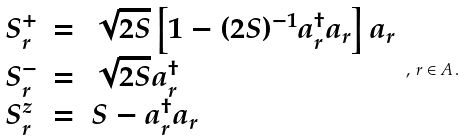<formula> <loc_0><loc_0><loc_500><loc_500>\begin{array} { l c l } S ^ { + } _ { r } & = & \sqrt { 2 S } \left [ 1 - ( 2 S ) ^ { - 1 } a _ { r } ^ { \dagger } a _ { r } \right ] a _ { r } \\ S ^ { - } _ { r } & = & \sqrt { 2 S } a ^ { \dagger } _ { r } \\ S ^ { z } _ { r } & = & S - a ^ { \dagger } _ { r } a _ { r } \end{array} \, , \, { r } \in A \, .</formula> 